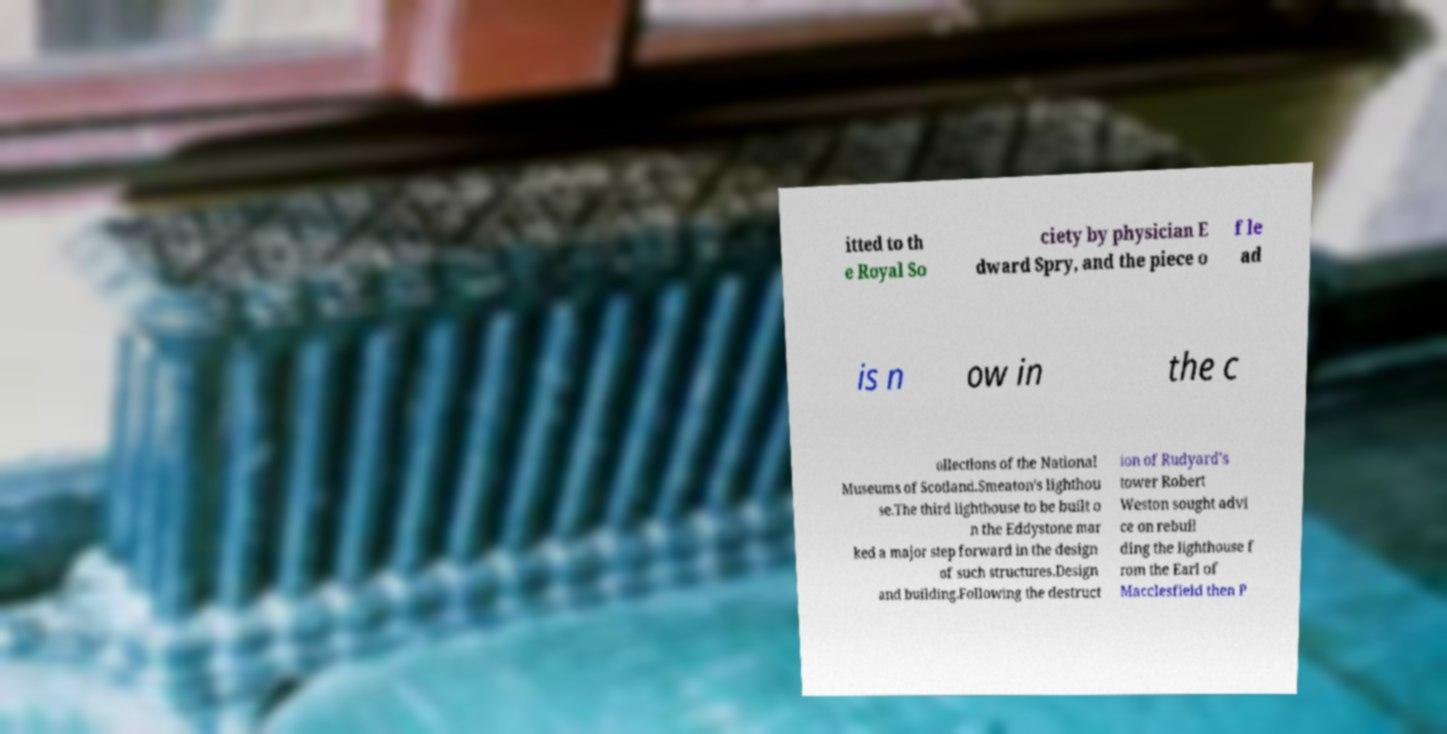Please identify and transcribe the text found in this image. itted to th e Royal So ciety by physician E dward Spry, and the piece o f le ad is n ow in the c ollections of the National Museums of Scotland.Smeaton's lighthou se.The third lighthouse to be built o n the Eddystone mar ked a major step forward in the design of such structures.Design and building.Following the destruct ion of Rudyard's tower Robert Weston sought advi ce on rebuil ding the lighthouse f rom the Earl of Macclesfield then P 